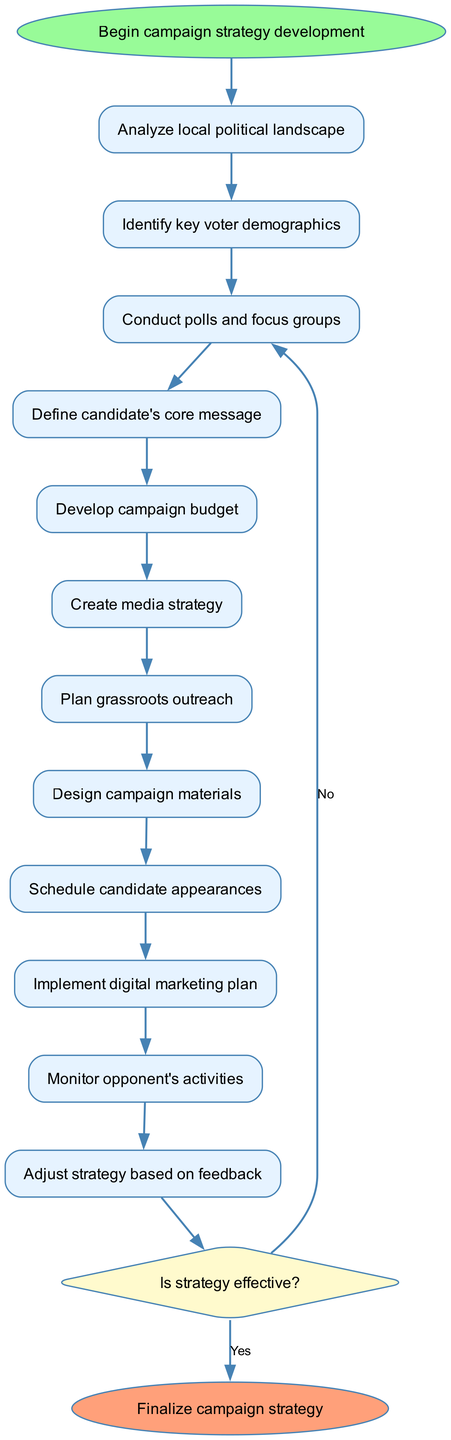What is the starting activity of the diagram? The starting activity is identified as "Begin campaign strategy development". This is indicated at the start of the activity diagram and is the initial node before any other activities.
Answer: Begin campaign strategy development How many activities are involved in the strategy development process? The diagram lists a total of 11 activities, starting from "Analyze local political landscape" to "Schedule candidate appearances". Each activity follows sequentially in the workflow.
Answer: 11 What activity comes before "Define candidate's core message"? The activity prior to "Define candidate's core message" is "Conduct polls and focus groups". The connections between these nodes show the flow from polling to message definition.
Answer: Conduct polls and focus groups What is the decision point in the diagram? The decision point is labeled "Is strategy effective?". This is highlighted as a diamond-shaped node, which signifies a pivotal question in the workflow that leads to different outcomes based on effectiveness.
Answer: Is strategy effective? What activity happens if the strategy is not effective? If the strategy is not effective, the diagram indicates that the process returns to "Conduct polls and focus groups". This looping connection demonstrates the need for reevaluation based on feedback.
Answer: Conduct polls and focus groups How does the activity "Monitor opponent's activities" connect to the overall strategy? "Monitor opponent's activities" serves as a step to gather information after implementing the digital marketing plan, and it leads directly to the decision point about strategy effectiveness. This illustrates its role in adjusting tactics according to external factors.
Answer: It connects to the decision point What is the final step in the campaign strategy development process? The final step, according to the diagram, is "Finalize campaign strategy". This is the concluding node that signifies the completion of the entire development process.
Answer: Finalize campaign strategy How many edges are present in the diagram? The diagram contains a total of 14 edges, which represent the connections or transitions between the various activities and the decision point throughout the campaign strategy development.
Answer: 14 What happens after the candidate appearances are scheduled? Once "Schedule candidate appearances" is completed, it leads to the next activity, "Implement digital marketing plan". This shows the sequenced progression towards execution following scheduling.
Answer: Implement digital marketing plan 